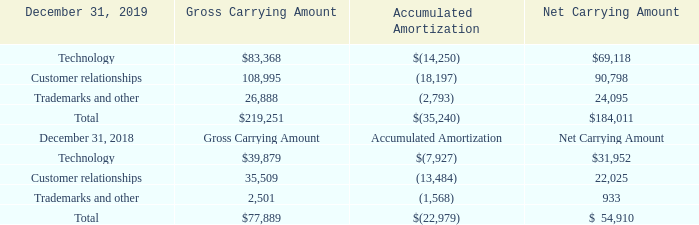ADVANCED ENERGY INDUSTRIES, INC. NOTES TO CONSOLIDATED FINANCIAL STATEMENTS – (continued) (in thousands, except per share amounts)
NOTE 13. INTANGIBLE ASSETS
Intangible assets consisted of the following as of December 31, 2019 and 2018:
At December 31, 2019, the weighted average remaining useful life of intangibles subject to amortization was approximately 11.2 years.
Which years does the table provide data for intangible assets? 2019, 2018. What was the gross carrying amount of Technology in 2019?
Answer scale should be: thousand. $83,368. What was the accumulated amortization of customer relationships in 2018?
Answer scale should be: thousand. (13,484). What is the sum of the two highest gross carrying amounts in 2019?
Answer scale should be: thousand. 83,368+108,995
Answer: 192363. What was the two highest net carrying amounts segments in 2018?
Answer scale should be: thousand. Find the 2 largest values for Rows 7 to 9, COL5 and the corresponding component in COL2
Answer: technology, customer relationships. What was the percentage change in the total gross carrying amount between 2018 and 2019?
Answer scale should be: percent. ($219,251-$77,889)/$77,889
Answer: 181.49. 